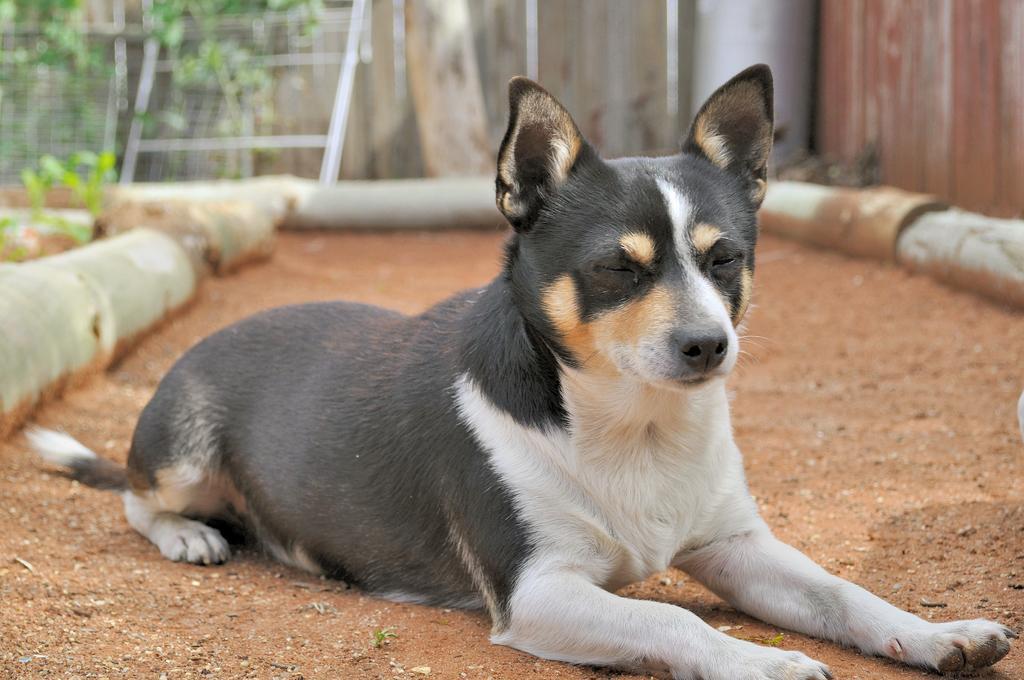Can you describe this image briefly? In this image in the center there is an animal. In the background there are plants and there is fence and there are pipes. 